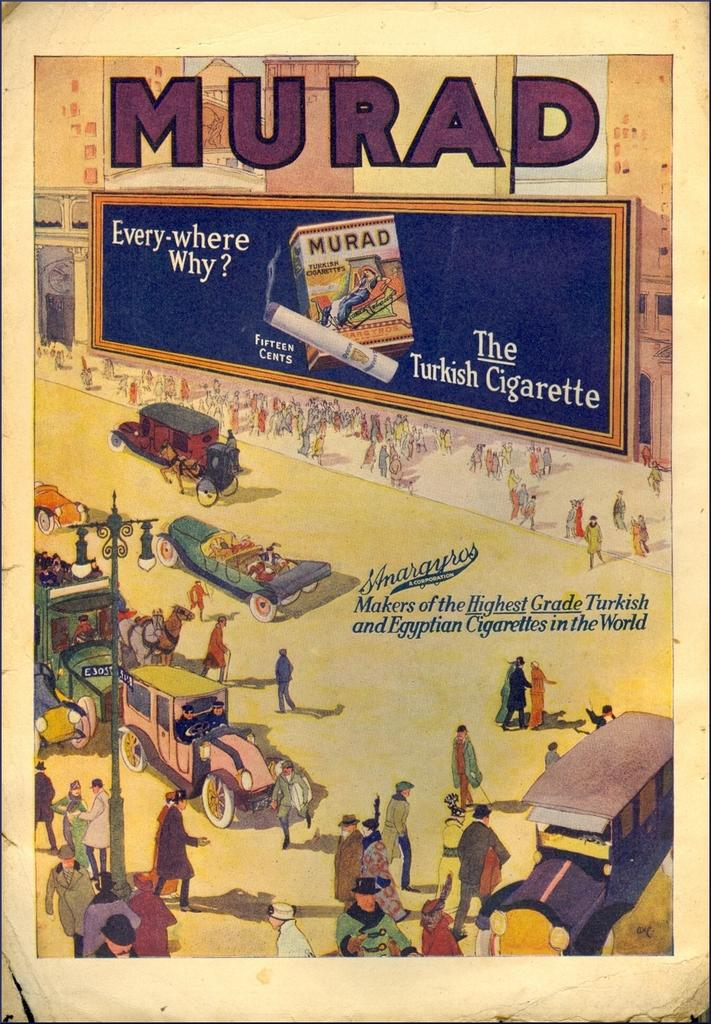What type of visual representation is shown in the image? The image is a poster. What subjects are depicted on the poster? There are vehicles and people depicted on the poster. Is there any text present on the poster? Yes, there is text present on the poster. How many feet of yarn are used to create the poster? The poster is not made of yarn, so it's not possible to determine the amount of yarn used. Additionally, the poster is a visual representation, not a physical object made of yarn. What is the level of pollution depicted in the poster? The provided facts do not mention any information about pollution, so it's not possible to determine the level of pollution depicted in the poster. 